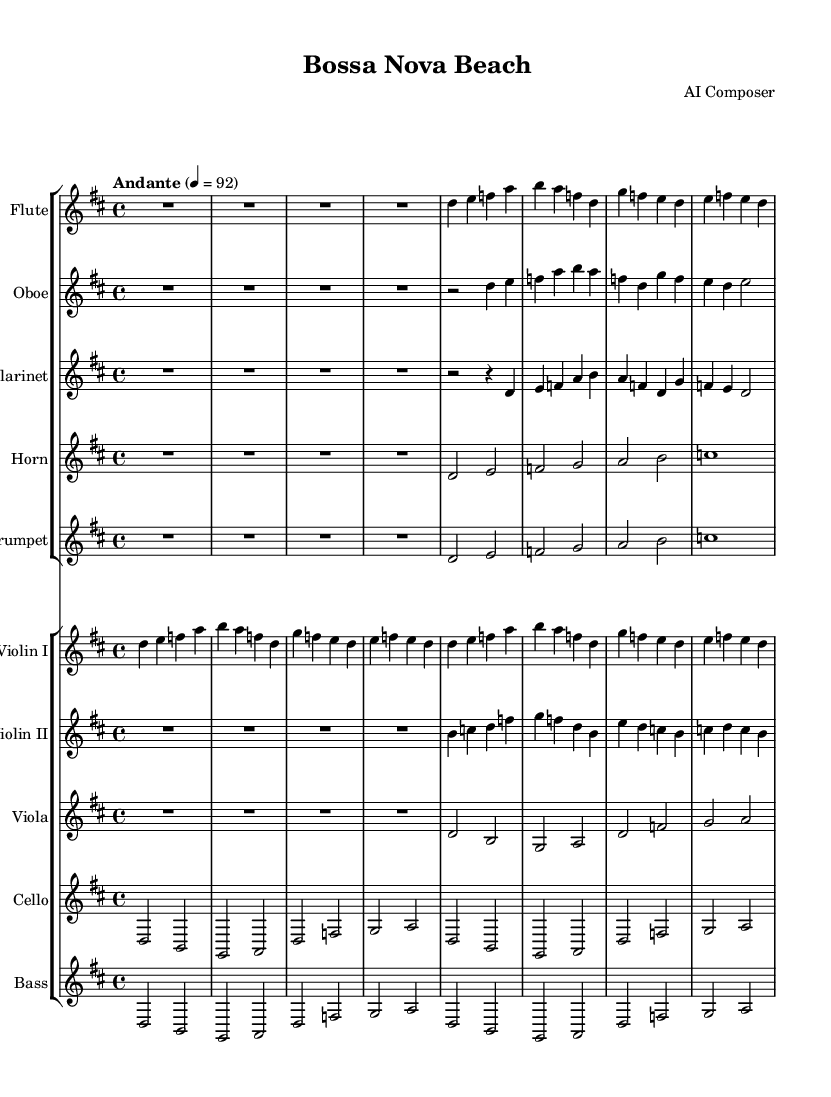What is the key signature of this music? The key signature is D major, which has two sharps (F# and C#).
Answer: D major What is the time signature of this music? The time signature is 4/4, indicating four beats per measure.
Answer: 4/4 What is the tempo marking of this music? The tempo marking is "Andante," indicating a moderately slow pace.
Answer: Andante How many instruments are included in the symphony? There are ten instruments listed, each in separate staffs.
Answer: Ten What is the first note played by the flute? The first note played by the flute is a rest, represented by "R1*4", meaning four beats of silence.
Answer: Rest Which instrument plays the melody most prominently? The violins play the melody most prominently, especially Violin I, which features the recognizable bossa nova melody.
Answer: Violin I What is the last note played in the cello part? The last note played in the cello part is an A, which is indicated by the note in the last measure.
Answer: A 